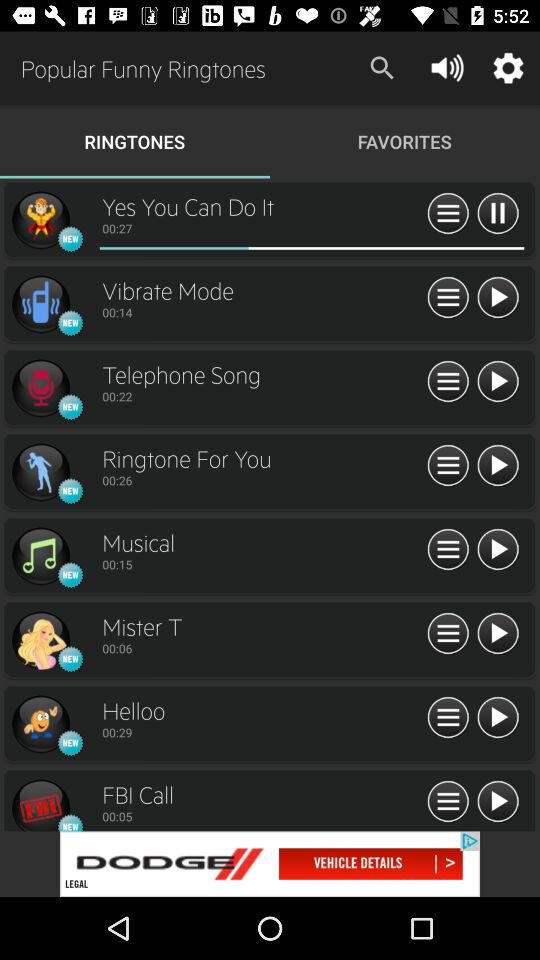What is the duration of the "Mister T" ringtone? The duration of the "Mister T" ringtone is 6 seconds. 